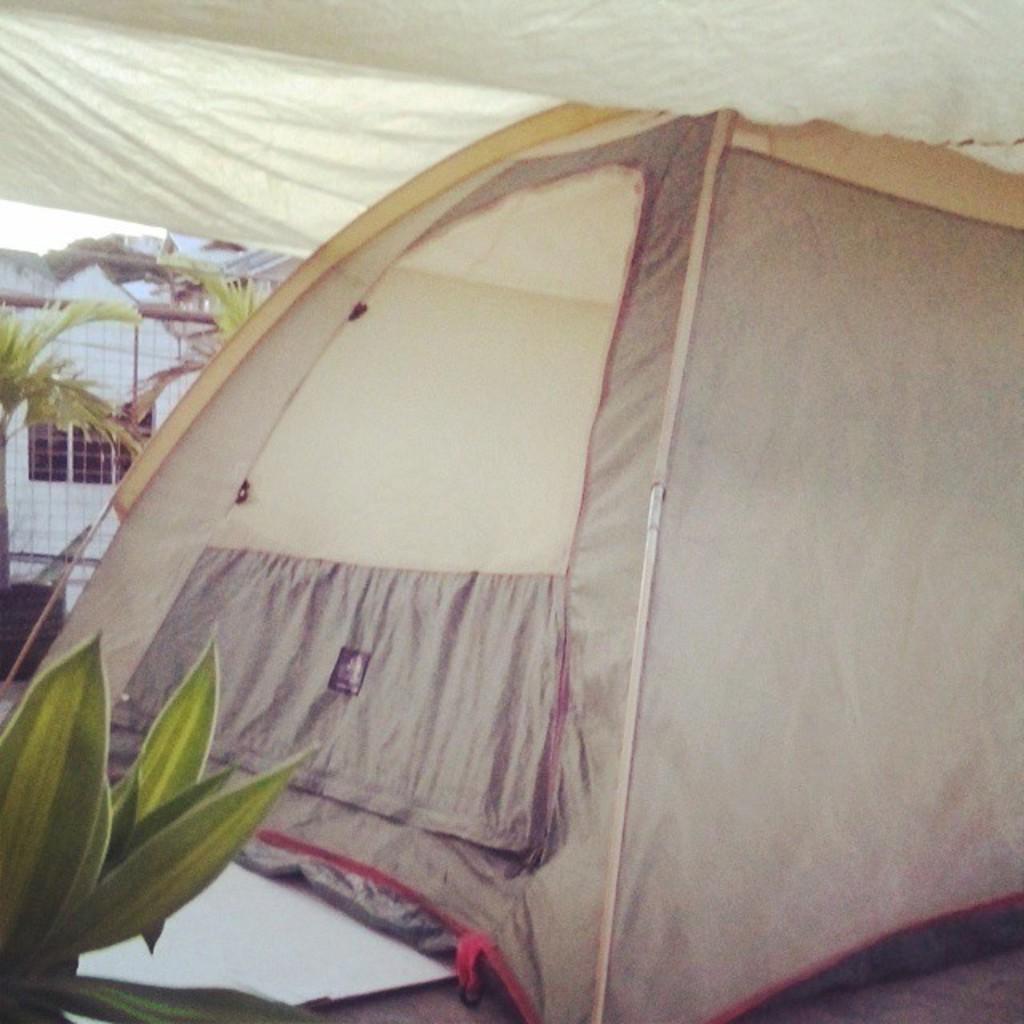How would you summarize this image in a sentence or two? In this image, we can see a tent. We can see the ground with a white colored object. We can also see some plants. We can see the fence and the wall. We can see the sky and a cloth on the top. 